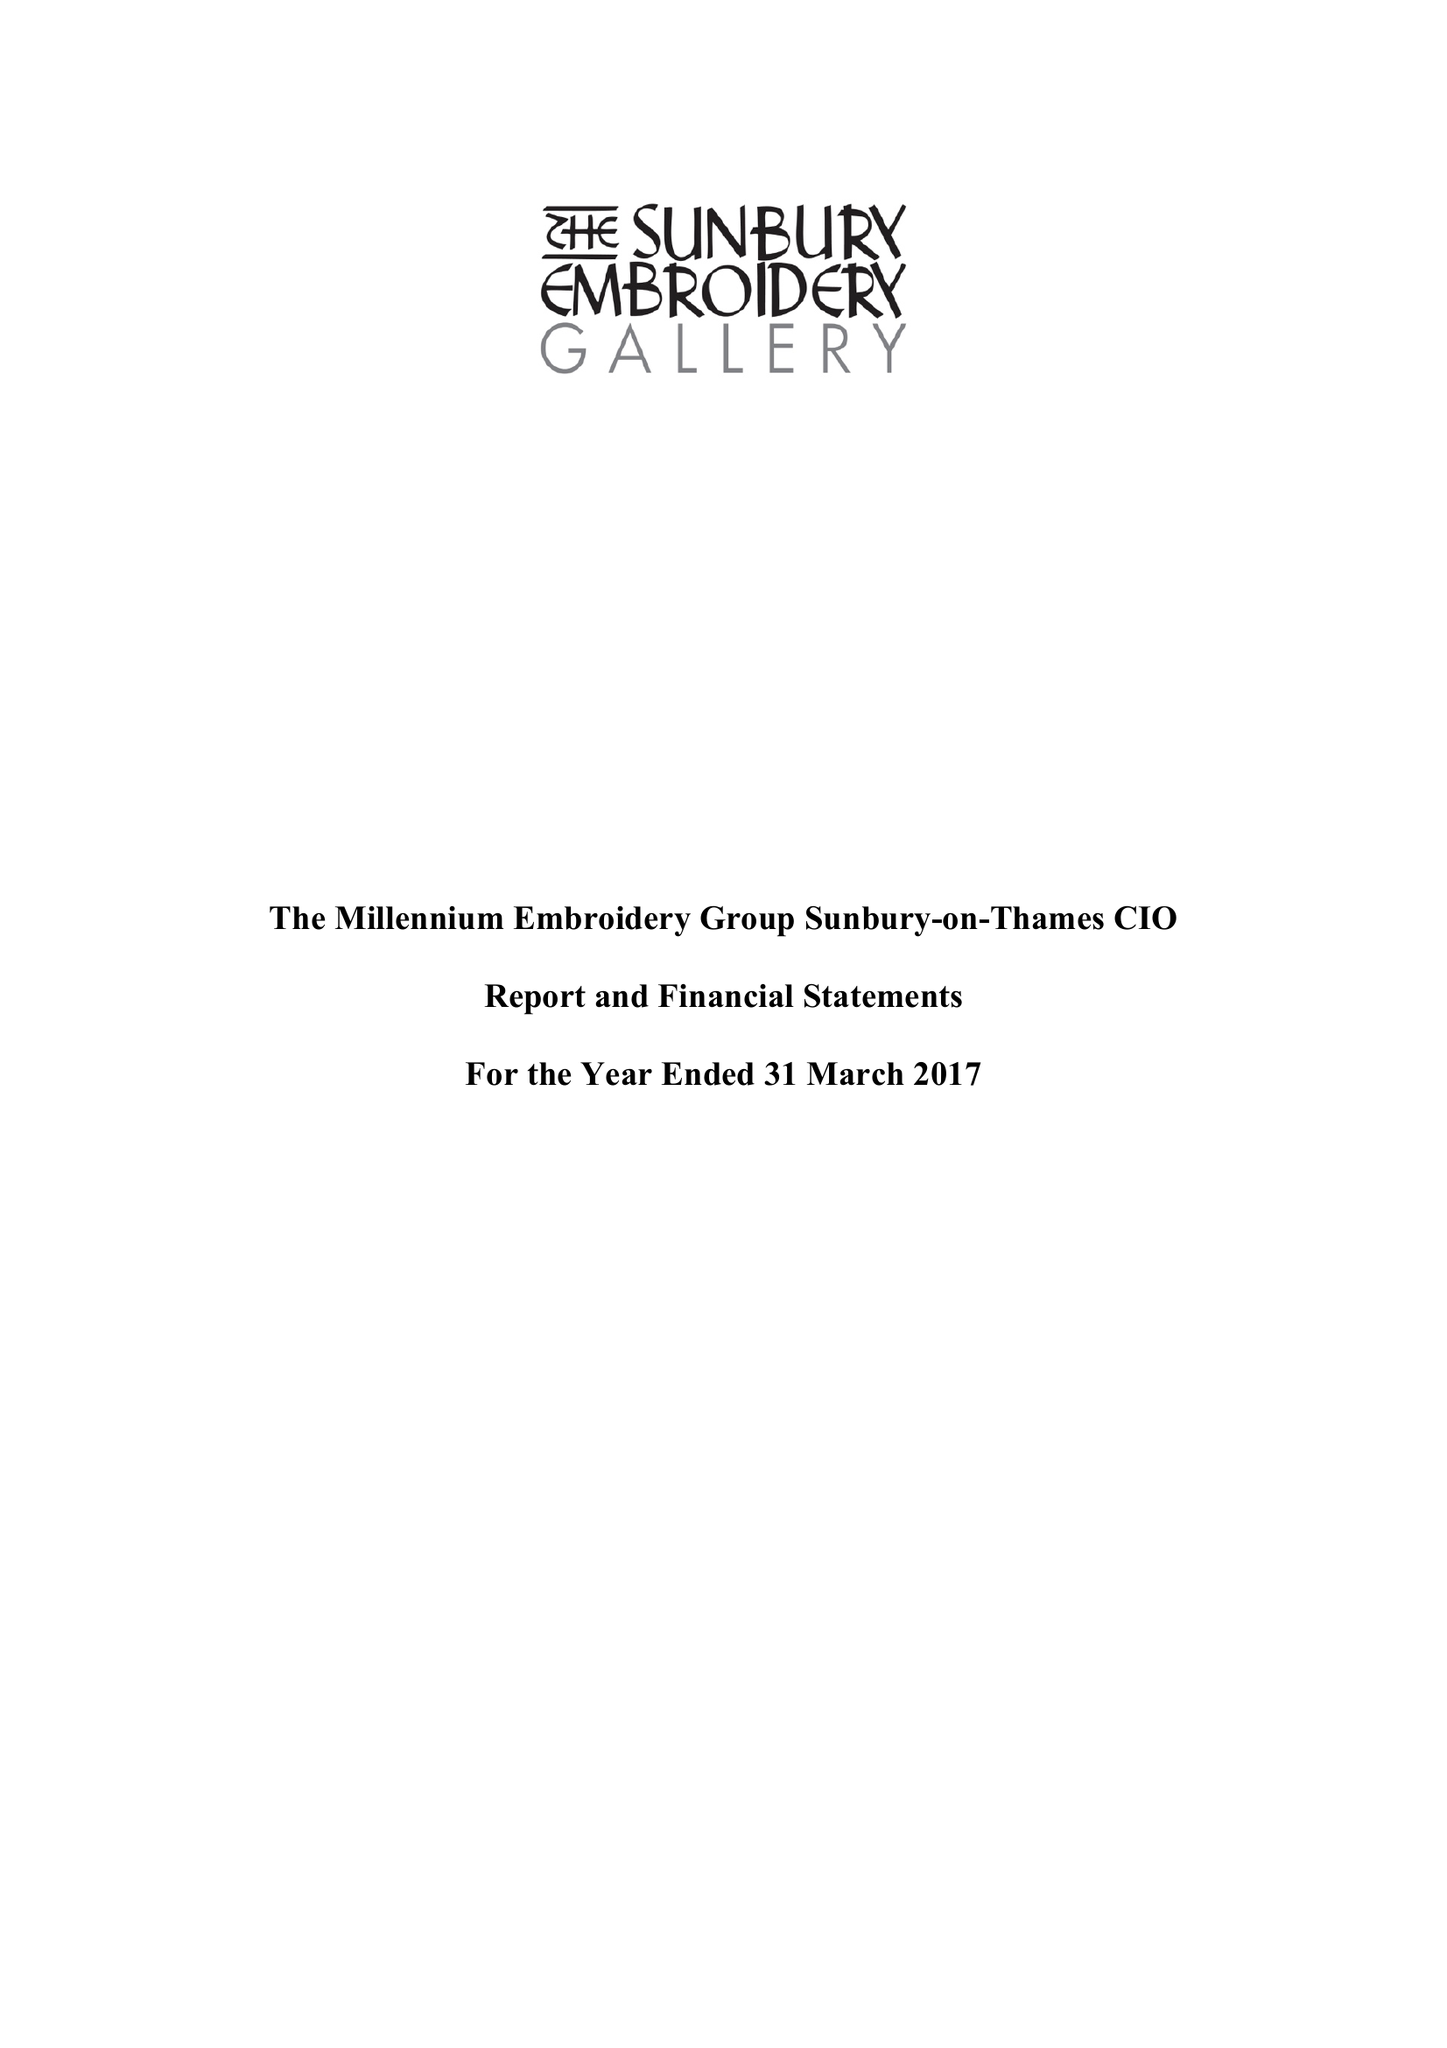What is the value for the income_annually_in_british_pounds?
Answer the question using a single word or phrase. 174560.00 